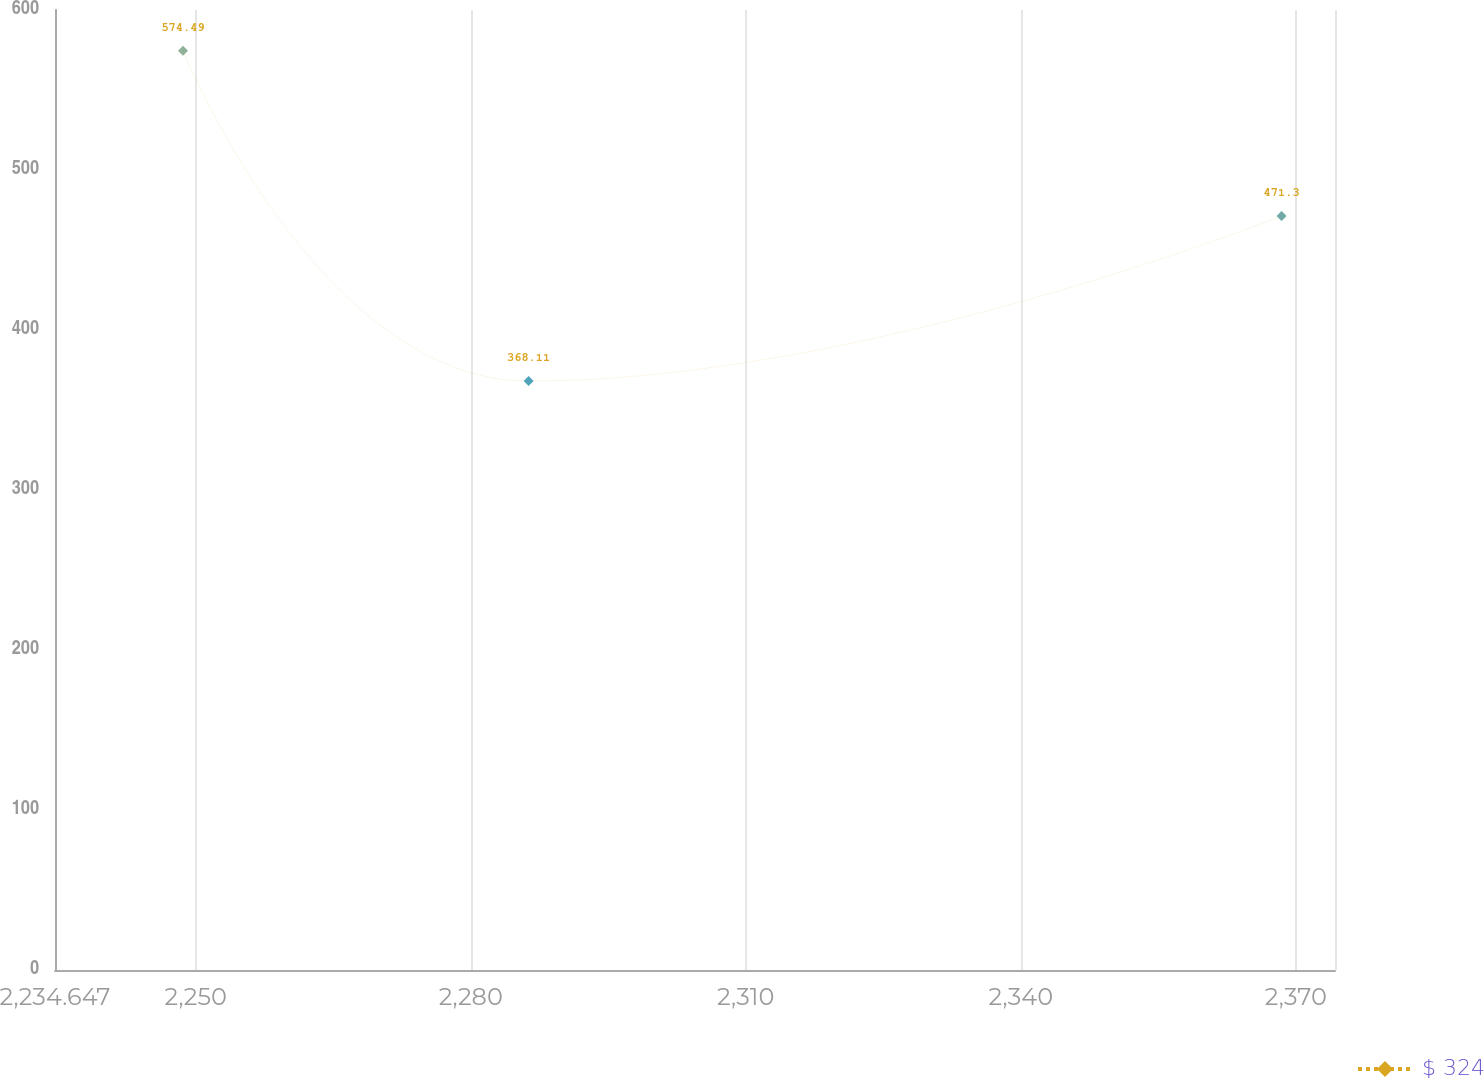<chart> <loc_0><loc_0><loc_500><loc_500><line_chart><ecel><fcel>$ 324<nl><fcel>2248.61<fcel>574.49<nl><fcel>2286.31<fcel>368.11<nl><fcel>2368.45<fcel>471.3<nl><fcel>2388.24<fcel>1399.98<nl></chart> 